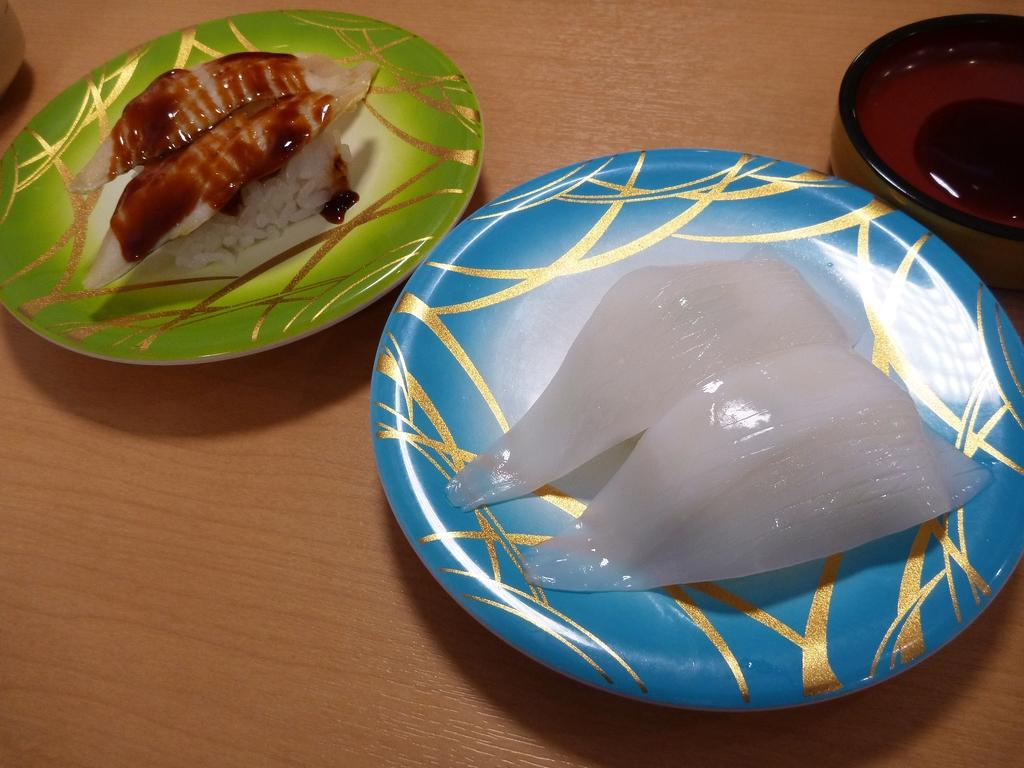What objects are in the center of the image? There are two plates in the center of the image. What is on the plates? There is food on the plates. Where are the bowls located in the image? There are bowls on the right and left sides of the image. What is the surface beneath the plates and bowls? There is a table at the bottom of the image. What type of observation can be made about the haircut of the person in the image? There is no person present in the image, so no haircut can be observed. What knowledge can be gained from the image about the nutritional value of the food? The image does not provide information about the nutritional value of the food; it only shows the presence of food on the plates. 